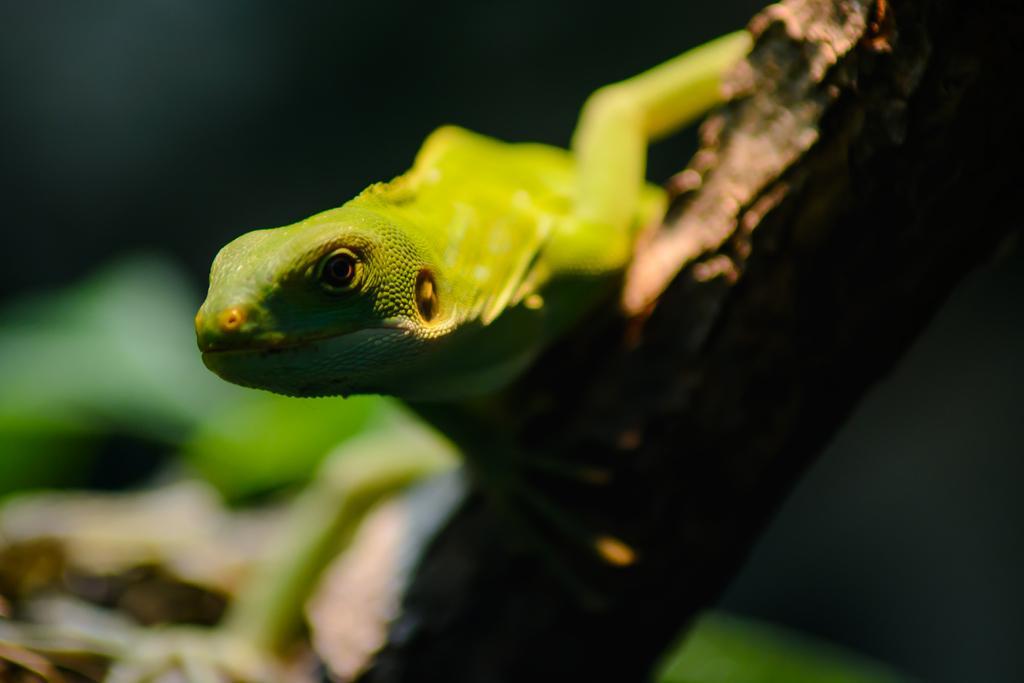How would you summarize this image in a sentence or two? In this picture, we see a reptile which looks like a chameleon is on the stem of the tree. It is green in color. In the background, it is in green and black color. This picture is blurred in the background. 